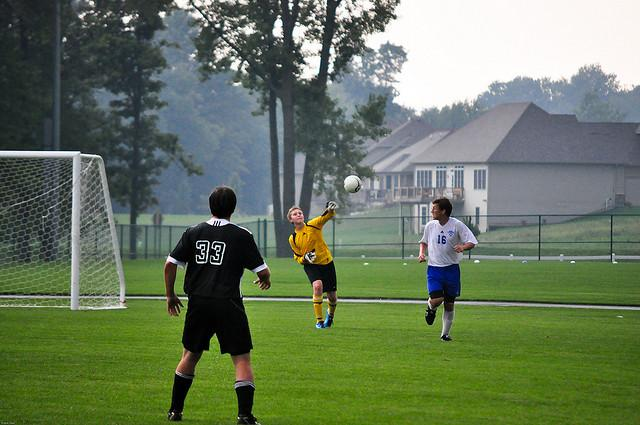Why is the one guy wearing a yellow uniform?

Choices:
A) spectator
B) referee
C) water boy
D) goalie goalie 